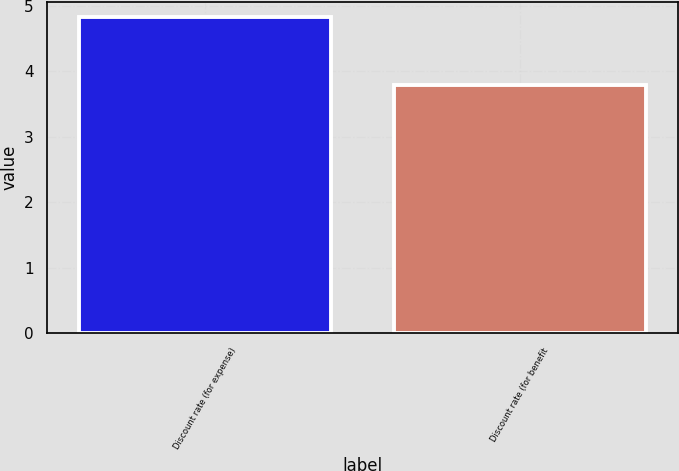<chart> <loc_0><loc_0><loc_500><loc_500><bar_chart><fcel>Discount rate (for expense)<fcel>Discount rate (for benefit<nl><fcel>4.82<fcel>3.79<nl></chart> 